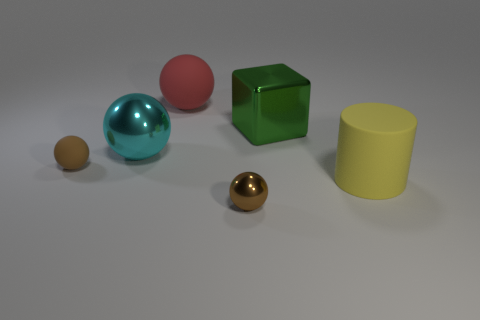Subtract all cyan spheres. How many spheres are left? 3 Subtract 1 balls. How many balls are left? 3 Subtract all green spheres. Subtract all green cubes. How many spheres are left? 4 Add 4 small brown spheres. How many objects exist? 10 Subtract all cylinders. How many objects are left? 5 Add 5 small spheres. How many small spheres are left? 7 Add 4 large rubber spheres. How many large rubber spheres exist? 5 Subtract 0 blue balls. How many objects are left? 6 Subtract all big red matte balls. Subtract all tiny green cylinders. How many objects are left? 5 